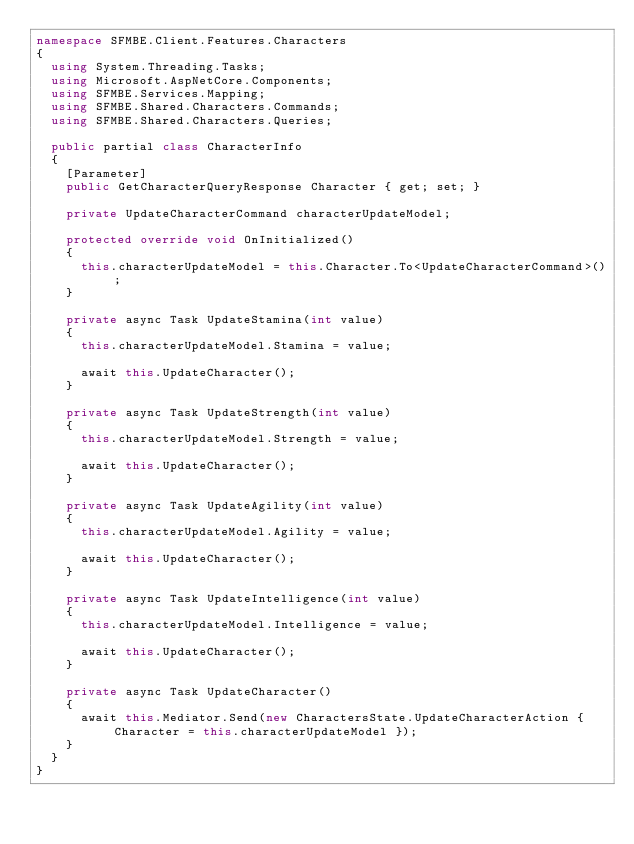<code> <loc_0><loc_0><loc_500><loc_500><_C#_>namespace SFMBE.Client.Features.Characters
{
  using System.Threading.Tasks;
  using Microsoft.AspNetCore.Components;
  using SFMBE.Services.Mapping;
  using SFMBE.Shared.Characters.Commands;
  using SFMBE.Shared.Characters.Queries;

  public partial class CharacterInfo
  {
    [Parameter]
    public GetCharacterQueryResponse Character { get; set; }

    private UpdateCharacterCommand characterUpdateModel;

    protected override void OnInitialized()
    {
      this.characterUpdateModel = this.Character.To<UpdateCharacterCommand>();
    }

    private async Task UpdateStamina(int value)
    {
      this.characterUpdateModel.Stamina = value;

      await this.UpdateCharacter();
    }

    private async Task UpdateStrength(int value)
    {
      this.characterUpdateModel.Strength = value;

      await this.UpdateCharacter();
    }

    private async Task UpdateAgility(int value)
    {
      this.characterUpdateModel.Agility = value;

      await this.UpdateCharacter();
    }

    private async Task UpdateIntelligence(int value)
    {
      this.characterUpdateModel.Intelligence = value;

      await this.UpdateCharacter();
    }

    private async Task UpdateCharacter()
    {
      await this.Mediator.Send(new CharactersState.UpdateCharacterAction { Character = this.characterUpdateModel });
    }
  }
}</code> 